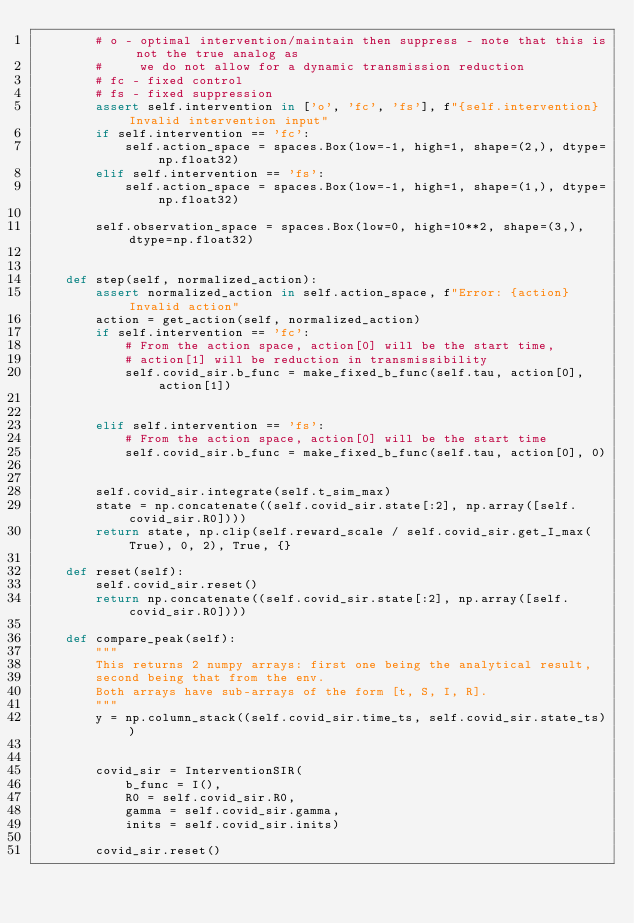Convert code to text. <code><loc_0><loc_0><loc_500><loc_500><_Python_>        # o - optimal intervention/maintain then suppress - note that this is not the true analog as
        #     we do not allow for a dynamic transmission reduction
        # fc - fixed control
        # fs - fixed suppression
        assert self.intervention in ['o', 'fc', 'fs'], f"{self.intervention} Invalid intervention input"
        if self.intervention == 'fc':
            self.action_space = spaces.Box(low=-1, high=1, shape=(2,), dtype=np.float32)
        elif self.intervention == 'fs':
            self.action_space = spaces.Box(low=-1, high=1, shape=(1,), dtype=np.float32)
        
        self.observation_space = spaces.Box(low=0, high=10**2, shape=(3,), dtype=np.float32)
        

    def step(self, normalized_action):
        assert normalized_action in self.action_space, f"Error: {action} Invalid action"
        action = get_action(self, normalized_action)
        if self.intervention == 'fc':
            # From the action space, action[0] will be the start time, 
            # action[1] will be reduction in transmissibility
            self.covid_sir.b_func = make_fixed_b_func(self.tau, action[0], action[1])

        
        elif self.intervention == 'fs':
            # From the action space, action[0] will be the start time
            self.covid_sir.b_func = make_fixed_b_func(self.tau, action[0], 0)

        
        self.covid_sir.integrate(self.t_sim_max)
        state = np.concatenate((self.covid_sir.state[:2], np.array([self.covid_sir.R0])))
        return state, np.clip(self.reward_scale / self.covid_sir.get_I_max(True), 0, 2), True, {}
    
    def reset(self):
        self.covid_sir.reset()
        return np.concatenate((self.covid_sir.state[:2], np.array([self.covid_sir.R0])))
    
    def compare_peak(self):
        """
        This returns 2 numpy arrays: first one being the analytical result,
        second being that from the env.
        Both arrays have sub-arrays of the form [t, S, I, R].
        """
        y = np.column_stack((self.covid_sir.time_ts, self.covid_sir.state_ts))
        
        
        covid_sir = InterventionSIR(
            b_func = I(),
            R0 = self.covid_sir.R0,
            gamma = self.covid_sir.gamma,
            inits = self.covid_sir.inits)
        
        covid_sir.reset()
        </code> 